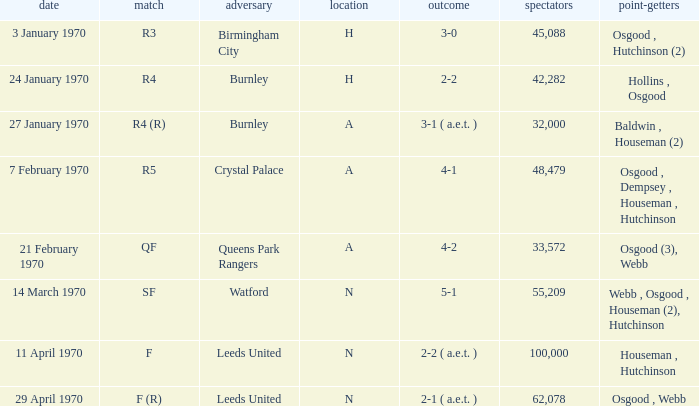In which round did the game at n venue have a score of 5-1? SF. 